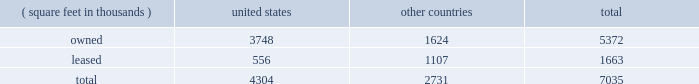Item 2 : properties information concerning applied's properties at october 25 , 2015 is set forth below: .
Because of the interrelation of applied's operations , properties within a country may be shared by the segments operating within that country .
The company's headquarters offices are in santa clara , california .
Products in silicon systems are manufactured in austin , texas ; gloucester , massachusetts ; rehovot , israel ; and singapore .
Remanufactured equipment products in the applied global services segment are produced primarily in austin , texas .
Products in the display segment are manufactured in tainan , taiwan and santa clara , california .
Products in the energy and environmental solutions segment are primarily manufactured in alzenau , germany and treviso , italy .
Applied also owns and leases offices , plants and warehouse locations in many locations throughout the world , including in europe , japan , north america ( principally the united states ) , israel , china , india , korea , southeast asia and taiwan .
These facilities are principally used for manufacturing ; research , development and engineering ; and marketing , sales and customer support .
Applied also owns a total of approximately 139 acres of buildable land in texas , california , israel and italy that could accommodate additional building space .
Applied considers the properties that it owns or leases as adequate to meet its current and future requirements .
Applied regularly assesses the size , capability and location of its global infrastructure and periodically makes adjustments based on these assessments. .
What portion of the company's property are leased? 
Computations: (1663 / 7035)
Answer: 0.23639. Item 2 : properties information concerning applied's properties at october 25 , 2015 is set forth below: .
Because of the interrelation of applied's operations , properties within a country may be shared by the segments operating within that country .
The company's headquarters offices are in santa clara , california .
Products in silicon systems are manufactured in austin , texas ; gloucester , massachusetts ; rehovot , israel ; and singapore .
Remanufactured equipment products in the applied global services segment are produced primarily in austin , texas .
Products in the display segment are manufactured in tainan , taiwan and santa clara , california .
Products in the energy and environmental solutions segment are primarily manufactured in alzenau , germany and treviso , italy .
Applied also owns and leases offices , plants and warehouse locations in many locations throughout the world , including in europe , japan , north america ( principally the united states ) , israel , china , india , korea , southeast asia and taiwan .
These facilities are principally used for manufacturing ; research , development and engineering ; and marketing , sales and customer support .
Applied also owns a total of approximately 139 acres of buildable land in texas , california , israel and italy that could accommodate additional building space .
Applied considers the properties that it owns or leases as adequate to meet its current and future requirements .
Applied regularly assesses the size , capability and location of its global infrastructure and periodically makes adjustments based on these assessments. .
Based on the table , how much more square feet is owned outside the united states? 
Rationale: this is a pretty self explanatory question but units are needed or the answer is incorrect .
Computations: (7035 - 4304)
Answer: 2731.0. 